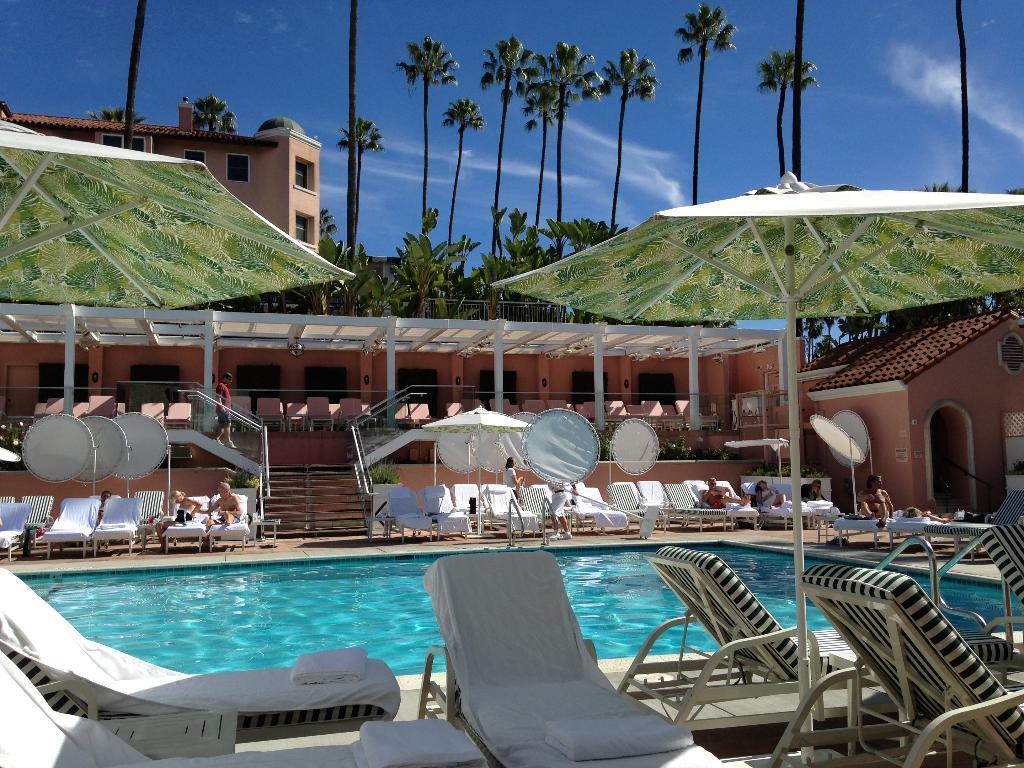Describe this image in one or two sentences. In this picture there are chairs under the umbrellas in the foreground. At the back there are group of people sitting on the chairs and there are umbrellas. At the back there is a building and there are trees. At the top there is sky and there are clouds. At the bottom there is water. 